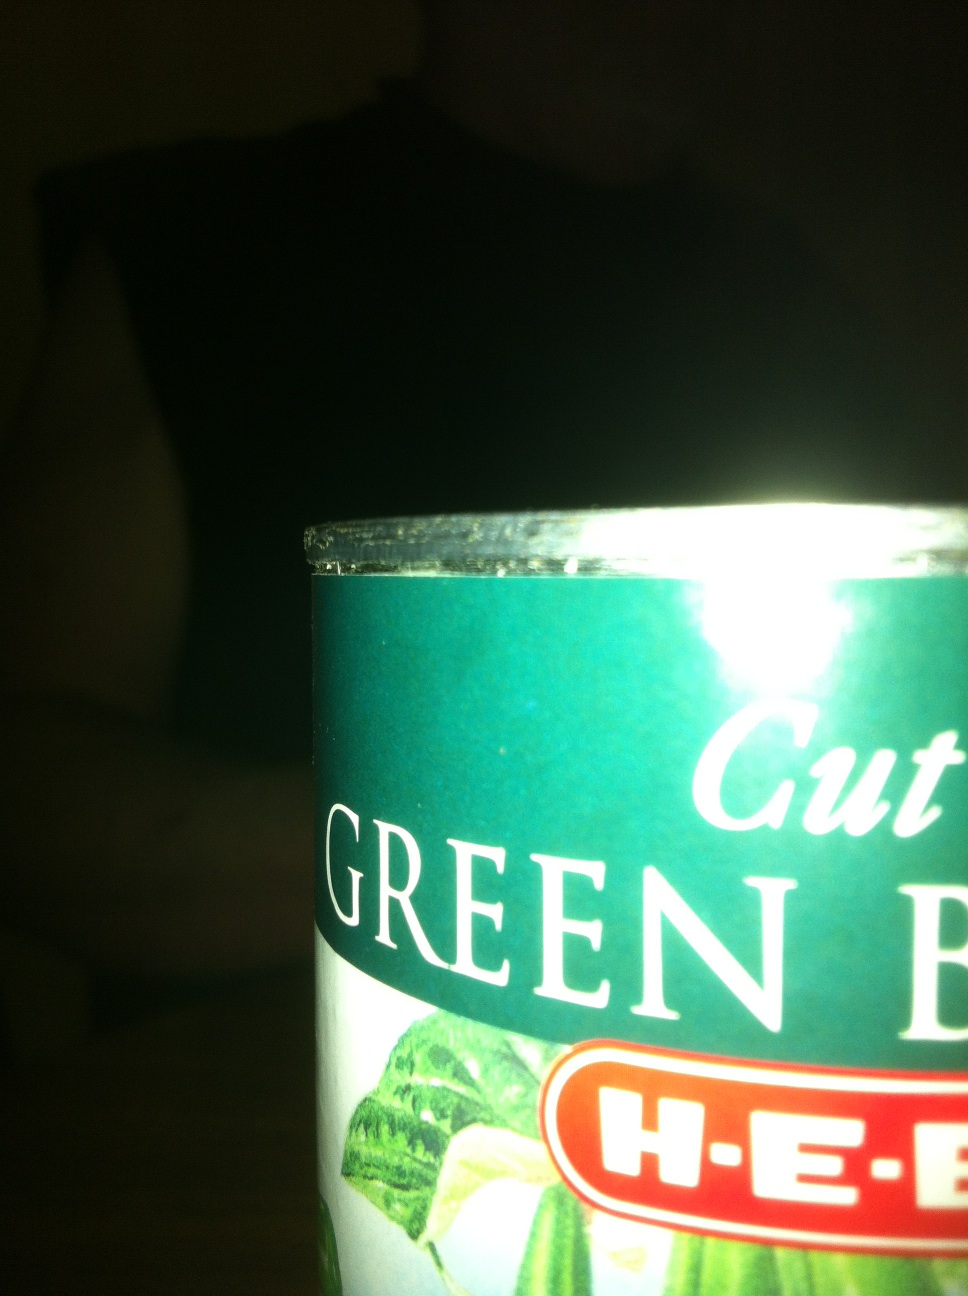What is this canned good please? Thank you. The canned good you're asking about is 'cut green beans.' It’s a product from H-E-B, which is a supermarket chain based in Texas, known for delivering various quality grocery products. 